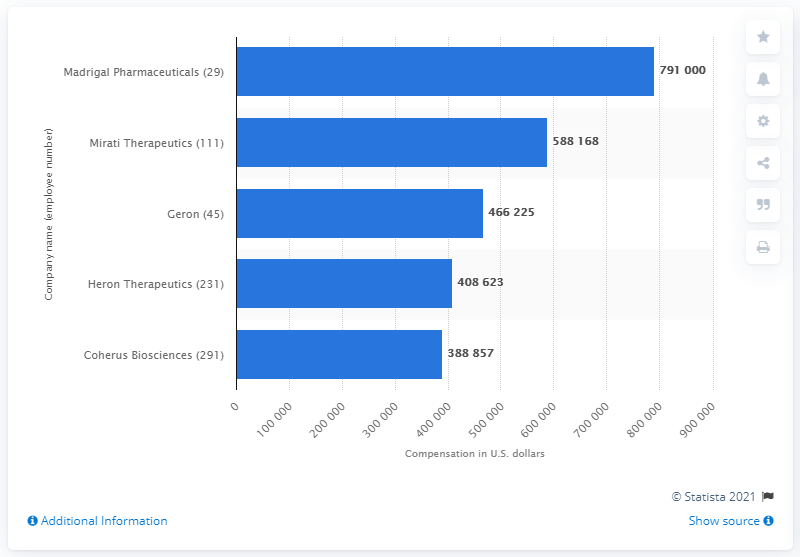Indicate a few pertinent items in this graphic. The median employee was paid 791,000 at Madrigal Pharma in 2019. 